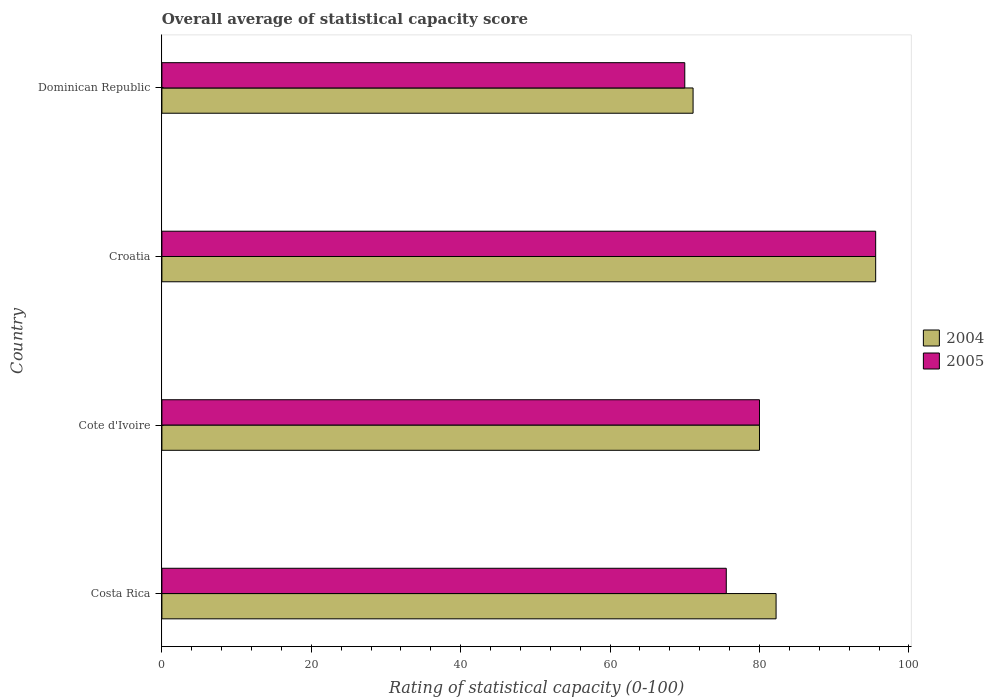How many different coloured bars are there?
Your response must be concise. 2. How many bars are there on the 1st tick from the bottom?
Give a very brief answer. 2. What is the label of the 4th group of bars from the top?
Provide a short and direct response. Costa Rica. In how many cases, is the number of bars for a given country not equal to the number of legend labels?
Offer a very short reply. 0. What is the rating of statistical capacity in 2004 in Croatia?
Ensure brevity in your answer.  95.56. Across all countries, what is the maximum rating of statistical capacity in 2005?
Offer a terse response. 95.56. In which country was the rating of statistical capacity in 2005 maximum?
Your response must be concise. Croatia. In which country was the rating of statistical capacity in 2005 minimum?
Your response must be concise. Dominican Republic. What is the total rating of statistical capacity in 2005 in the graph?
Keep it short and to the point. 321.11. What is the difference between the rating of statistical capacity in 2004 in Costa Rica and that in Dominican Republic?
Make the answer very short. 11.11. What is the difference between the rating of statistical capacity in 2005 in Cote d'Ivoire and the rating of statistical capacity in 2004 in Croatia?
Keep it short and to the point. -15.56. What is the average rating of statistical capacity in 2005 per country?
Offer a terse response. 80.28. What is the difference between the rating of statistical capacity in 2005 and rating of statistical capacity in 2004 in Dominican Republic?
Offer a very short reply. -1.11. In how many countries, is the rating of statistical capacity in 2004 greater than 92 ?
Provide a short and direct response. 1. What is the ratio of the rating of statistical capacity in 2005 in Costa Rica to that in Cote d'Ivoire?
Provide a succinct answer. 0.94. Is the rating of statistical capacity in 2004 in Croatia less than that in Dominican Republic?
Provide a succinct answer. No. Is the difference between the rating of statistical capacity in 2005 in Cote d'Ivoire and Dominican Republic greater than the difference between the rating of statistical capacity in 2004 in Cote d'Ivoire and Dominican Republic?
Your answer should be compact. Yes. What is the difference between the highest and the second highest rating of statistical capacity in 2004?
Your answer should be very brief. 13.33. What is the difference between the highest and the lowest rating of statistical capacity in 2004?
Provide a succinct answer. 24.44. What does the 1st bar from the top in Costa Rica represents?
Give a very brief answer. 2005. How many bars are there?
Make the answer very short. 8. What is the difference between two consecutive major ticks on the X-axis?
Make the answer very short. 20. Are the values on the major ticks of X-axis written in scientific E-notation?
Your response must be concise. No. How many legend labels are there?
Your response must be concise. 2. What is the title of the graph?
Provide a short and direct response. Overall average of statistical capacity score. What is the label or title of the X-axis?
Offer a terse response. Rating of statistical capacity (0-100). What is the label or title of the Y-axis?
Provide a succinct answer. Country. What is the Rating of statistical capacity (0-100) in 2004 in Costa Rica?
Your answer should be compact. 82.22. What is the Rating of statistical capacity (0-100) in 2005 in Costa Rica?
Offer a very short reply. 75.56. What is the Rating of statistical capacity (0-100) in 2005 in Cote d'Ivoire?
Offer a terse response. 80. What is the Rating of statistical capacity (0-100) in 2004 in Croatia?
Ensure brevity in your answer.  95.56. What is the Rating of statistical capacity (0-100) in 2005 in Croatia?
Your answer should be very brief. 95.56. What is the Rating of statistical capacity (0-100) of 2004 in Dominican Republic?
Offer a terse response. 71.11. Across all countries, what is the maximum Rating of statistical capacity (0-100) of 2004?
Offer a very short reply. 95.56. Across all countries, what is the maximum Rating of statistical capacity (0-100) of 2005?
Give a very brief answer. 95.56. Across all countries, what is the minimum Rating of statistical capacity (0-100) of 2004?
Provide a succinct answer. 71.11. Across all countries, what is the minimum Rating of statistical capacity (0-100) of 2005?
Keep it short and to the point. 70. What is the total Rating of statistical capacity (0-100) of 2004 in the graph?
Your response must be concise. 328.89. What is the total Rating of statistical capacity (0-100) of 2005 in the graph?
Offer a terse response. 321.11. What is the difference between the Rating of statistical capacity (0-100) of 2004 in Costa Rica and that in Cote d'Ivoire?
Keep it short and to the point. 2.22. What is the difference between the Rating of statistical capacity (0-100) of 2005 in Costa Rica and that in Cote d'Ivoire?
Provide a succinct answer. -4.44. What is the difference between the Rating of statistical capacity (0-100) of 2004 in Costa Rica and that in Croatia?
Offer a very short reply. -13.33. What is the difference between the Rating of statistical capacity (0-100) of 2005 in Costa Rica and that in Croatia?
Your answer should be compact. -20. What is the difference between the Rating of statistical capacity (0-100) of 2004 in Costa Rica and that in Dominican Republic?
Your response must be concise. 11.11. What is the difference between the Rating of statistical capacity (0-100) in 2005 in Costa Rica and that in Dominican Republic?
Your response must be concise. 5.56. What is the difference between the Rating of statistical capacity (0-100) in 2004 in Cote d'Ivoire and that in Croatia?
Offer a terse response. -15.56. What is the difference between the Rating of statistical capacity (0-100) in 2005 in Cote d'Ivoire and that in Croatia?
Offer a very short reply. -15.56. What is the difference between the Rating of statistical capacity (0-100) in 2004 in Cote d'Ivoire and that in Dominican Republic?
Provide a short and direct response. 8.89. What is the difference between the Rating of statistical capacity (0-100) of 2005 in Cote d'Ivoire and that in Dominican Republic?
Ensure brevity in your answer.  10. What is the difference between the Rating of statistical capacity (0-100) of 2004 in Croatia and that in Dominican Republic?
Provide a succinct answer. 24.44. What is the difference between the Rating of statistical capacity (0-100) of 2005 in Croatia and that in Dominican Republic?
Ensure brevity in your answer.  25.56. What is the difference between the Rating of statistical capacity (0-100) of 2004 in Costa Rica and the Rating of statistical capacity (0-100) of 2005 in Cote d'Ivoire?
Provide a short and direct response. 2.22. What is the difference between the Rating of statistical capacity (0-100) in 2004 in Costa Rica and the Rating of statistical capacity (0-100) in 2005 in Croatia?
Ensure brevity in your answer.  -13.33. What is the difference between the Rating of statistical capacity (0-100) of 2004 in Costa Rica and the Rating of statistical capacity (0-100) of 2005 in Dominican Republic?
Keep it short and to the point. 12.22. What is the difference between the Rating of statistical capacity (0-100) of 2004 in Cote d'Ivoire and the Rating of statistical capacity (0-100) of 2005 in Croatia?
Make the answer very short. -15.56. What is the difference between the Rating of statistical capacity (0-100) of 2004 in Croatia and the Rating of statistical capacity (0-100) of 2005 in Dominican Republic?
Provide a succinct answer. 25.56. What is the average Rating of statistical capacity (0-100) of 2004 per country?
Your response must be concise. 82.22. What is the average Rating of statistical capacity (0-100) of 2005 per country?
Your response must be concise. 80.28. What is the difference between the Rating of statistical capacity (0-100) in 2004 and Rating of statistical capacity (0-100) in 2005 in Costa Rica?
Give a very brief answer. 6.67. What is the difference between the Rating of statistical capacity (0-100) of 2004 and Rating of statistical capacity (0-100) of 2005 in Croatia?
Provide a succinct answer. 0. What is the difference between the Rating of statistical capacity (0-100) of 2004 and Rating of statistical capacity (0-100) of 2005 in Dominican Republic?
Ensure brevity in your answer.  1.11. What is the ratio of the Rating of statistical capacity (0-100) in 2004 in Costa Rica to that in Cote d'Ivoire?
Offer a very short reply. 1.03. What is the ratio of the Rating of statistical capacity (0-100) in 2005 in Costa Rica to that in Cote d'Ivoire?
Your response must be concise. 0.94. What is the ratio of the Rating of statistical capacity (0-100) of 2004 in Costa Rica to that in Croatia?
Offer a terse response. 0.86. What is the ratio of the Rating of statistical capacity (0-100) in 2005 in Costa Rica to that in Croatia?
Your response must be concise. 0.79. What is the ratio of the Rating of statistical capacity (0-100) in 2004 in Costa Rica to that in Dominican Republic?
Ensure brevity in your answer.  1.16. What is the ratio of the Rating of statistical capacity (0-100) of 2005 in Costa Rica to that in Dominican Republic?
Offer a terse response. 1.08. What is the ratio of the Rating of statistical capacity (0-100) in 2004 in Cote d'Ivoire to that in Croatia?
Give a very brief answer. 0.84. What is the ratio of the Rating of statistical capacity (0-100) in 2005 in Cote d'Ivoire to that in Croatia?
Your response must be concise. 0.84. What is the ratio of the Rating of statistical capacity (0-100) of 2004 in Cote d'Ivoire to that in Dominican Republic?
Keep it short and to the point. 1.12. What is the ratio of the Rating of statistical capacity (0-100) of 2005 in Cote d'Ivoire to that in Dominican Republic?
Give a very brief answer. 1.14. What is the ratio of the Rating of statistical capacity (0-100) in 2004 in Croatia to that in Dominican Republic?
Keep it short and to the point. 1.34. What is the ratio of the Rating of statistical capacity (0-100) of 2005 in Croatia to that in Dominican Republic?
Keep it short and to the point. 1.37. What is the difference between the highest and the second highest Rating of statistical capacity (0-100) in 2004?
Offer a very short reply. 13.33. What is the difference between the highest and the second highest Rating of statistical capacity (0-100) of 2005?
Keep it short and to the point. 15.56. What is the difference between the highest and the lowest Rating of statistical capacity (0-100) of 2004?
Provide a short and direct response. 24.44. What is the difference between the highest and the lowest Rating of statistical capacity (0-100) in 2005?
Keep it short and to the point. 25.56. 